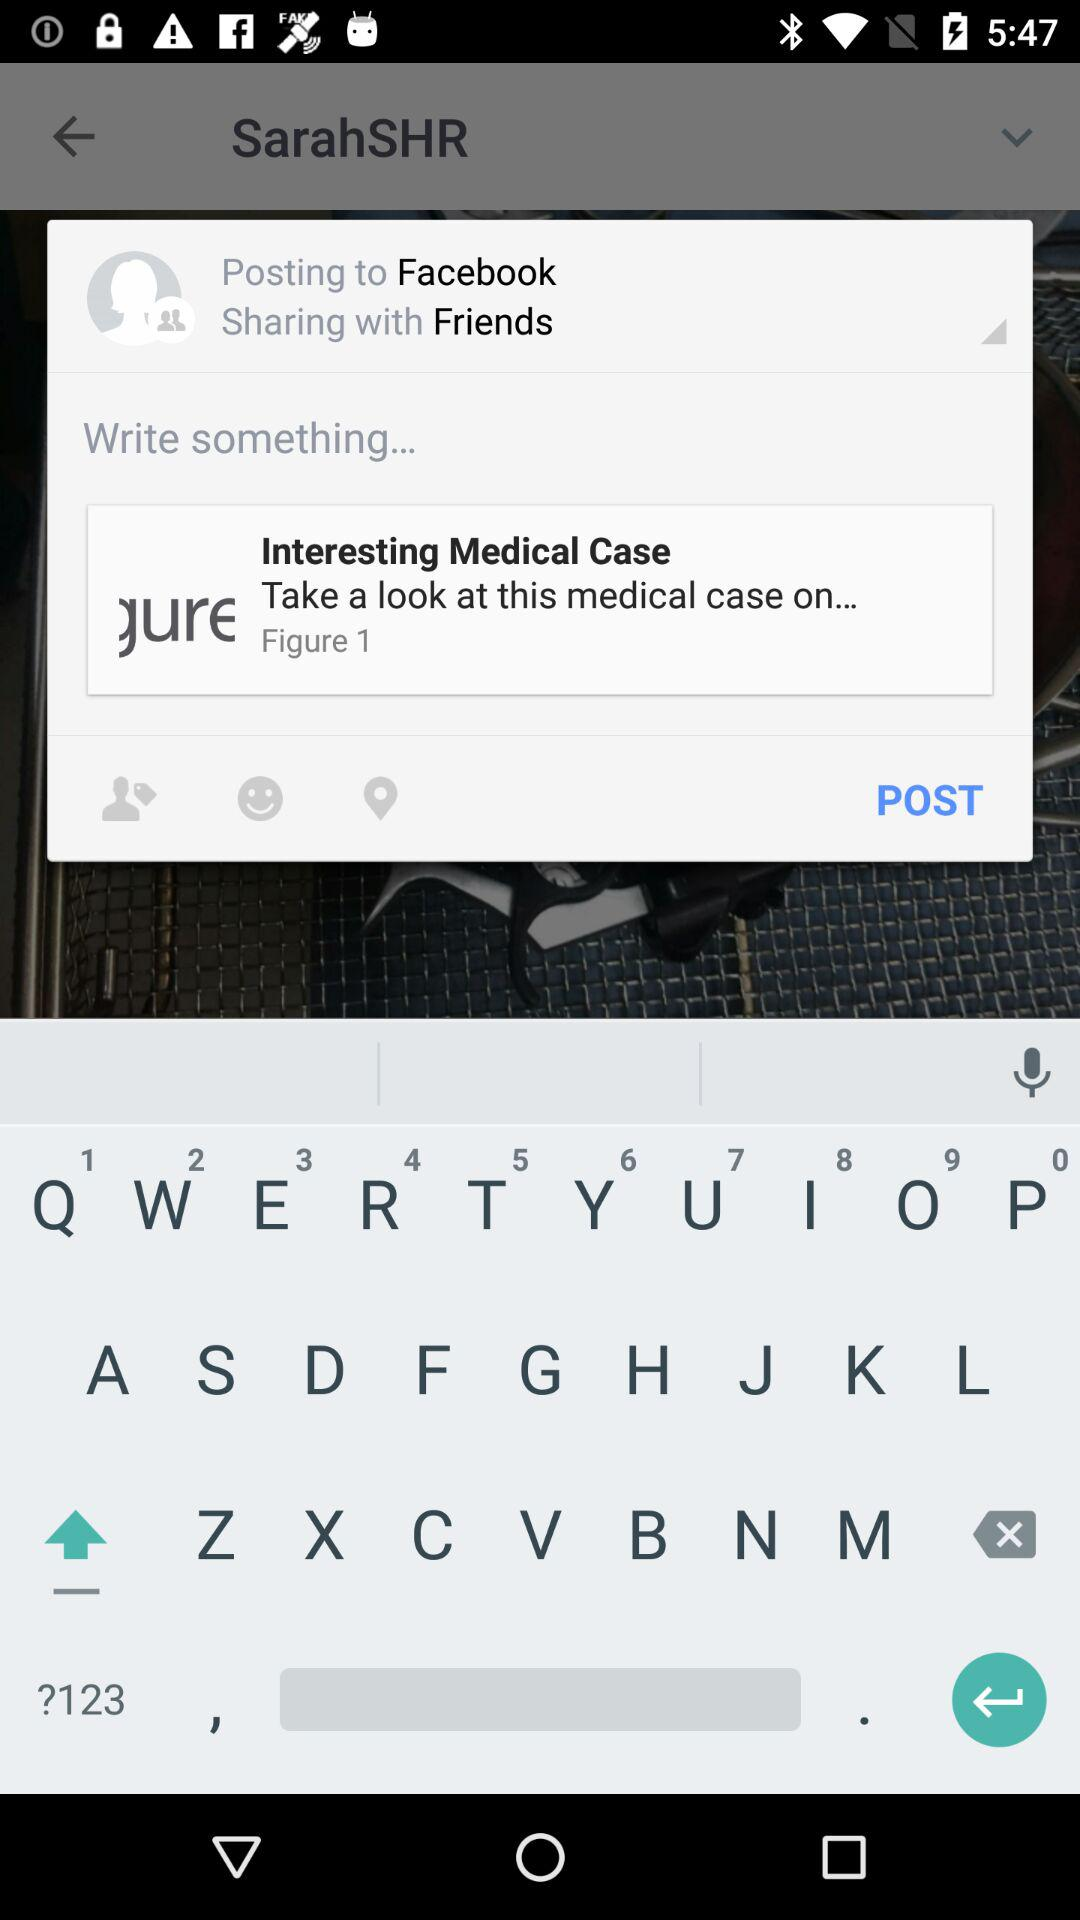What is the occupation of the student? The occupation is "Acupuncturist Student". 